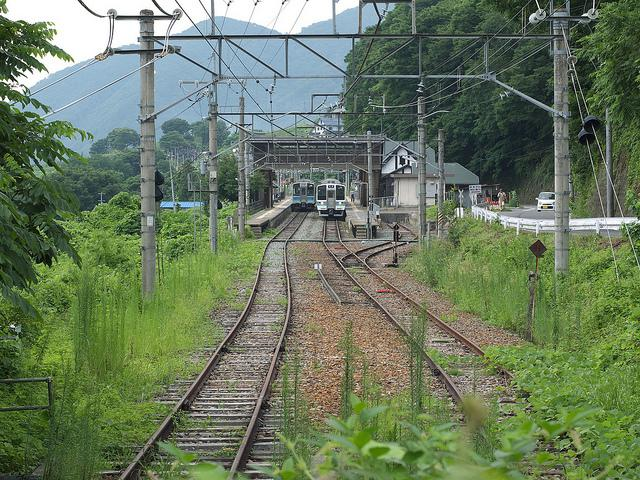There are two trains going down the rail of likely what country? Please explain your reasoning. japan. This asian country uses trains on its hilly terrain. 